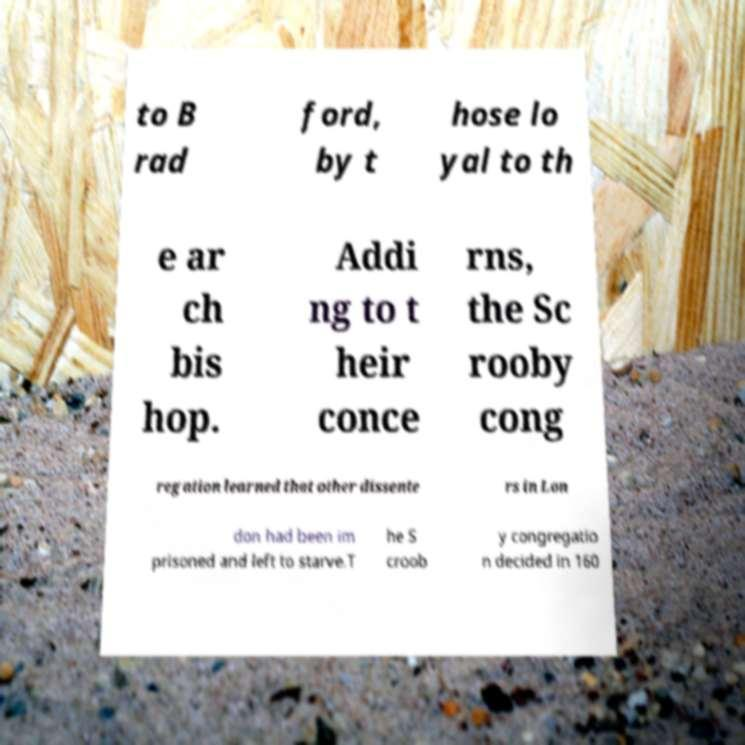Could you extract and type out the text from this image? to B rad ford, by t hose lo yal to th e ar ch bis hop. Addi ng to t heir conce rns, the Sc rooby cong regation learned that other dissente rs in Lon don had been im prisoned and left to starve.T he S croob y congregatio n decided in 160 